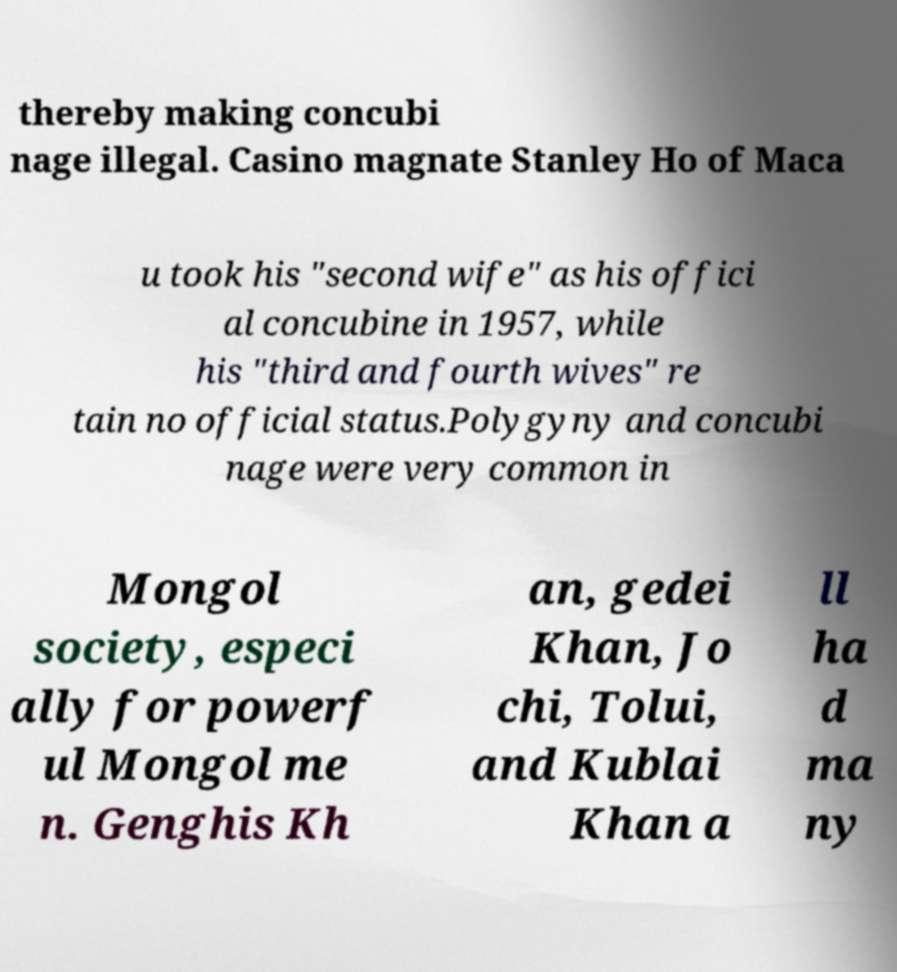For documentation purposes, I need the text within this image transcribed. Could you provide that? thereby making concubi nage illegal. Casino magnate Stanley Ho of Maca u took his "second wife" as his offici al concubine in 1957, while his "third and fourth wives" re tain no official status.Polygyny and concubi nage were very common in Mongol society, especi ally for powerf ul Mongol me n. Genghis Kh an, gedei Khan, Jo chi, Tolui, and Kublai Khan a ll ha d ma ny 